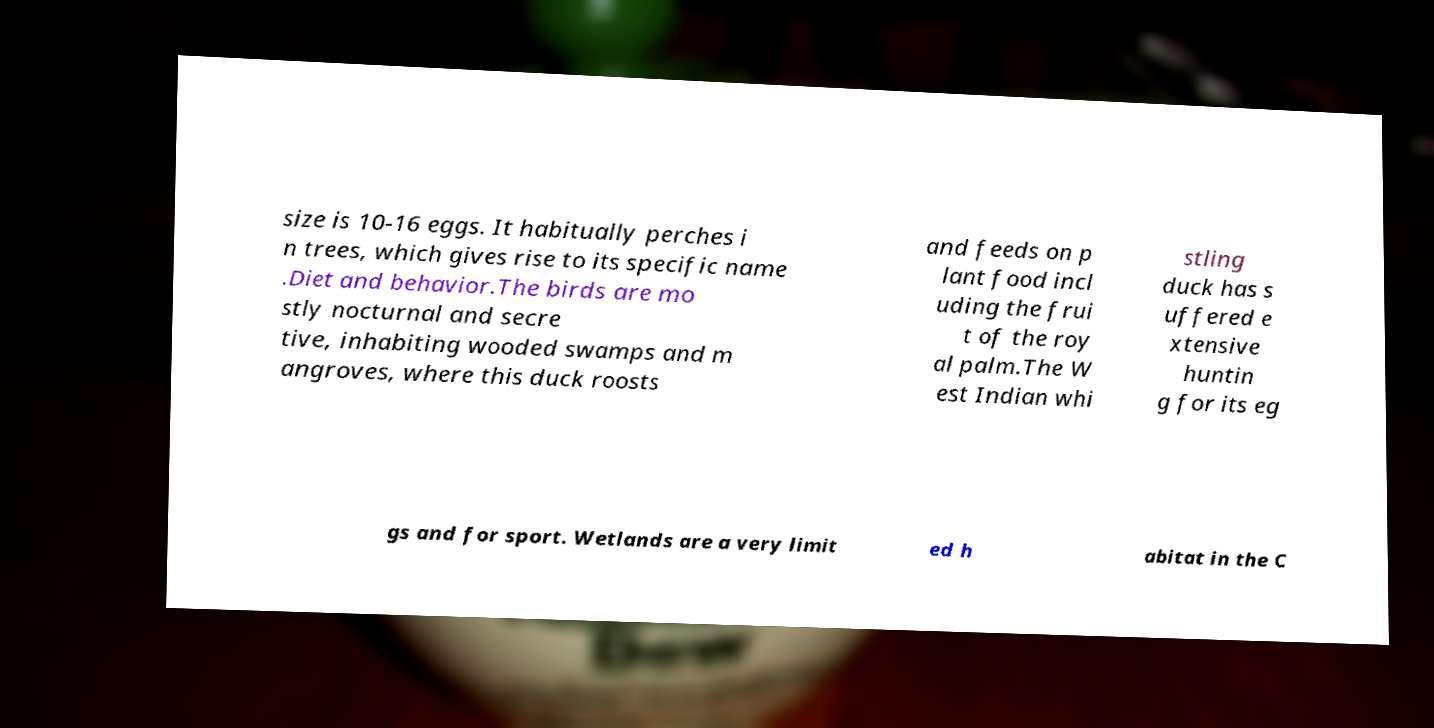Could you assist in decoding the text presented in this image and type it out clearly? size is 10-16 eggs. It habitually perches i n trees, which gives rise to its specific name .Diet and behavior.The birds are mo stly nocturnal and secre tive, inhabiting wooded swamps and m angroves, where this duck roosts and feeds on p lant food incl uding the frui t of the roy al palm.The W est Indian whi stling duck has s uffered e xtensive huntin g for its eg gs and for sport. Wetlands are a very limit ed h abitat in the C 